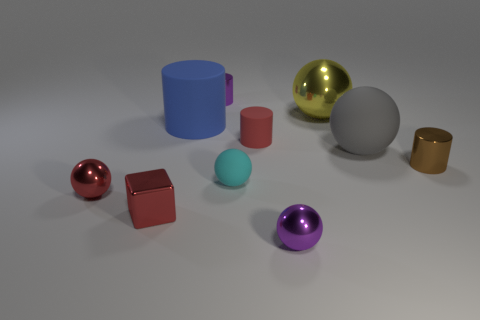Subtract 3 balls. How many balls are left? 2 Subtract all yellow spheres. How many spheres are left? 4 Subtract all purple shiny cylinders. How many cylinders are left? 3 Subtract all green cylinders. Subtract all gray blocks. How many cylinders are left? 4 Subtract all cylinders. How many objects are left? 6 Subtract 0 green blocks. How many objects are left? 10 Subtract all yellow matte cylinders. Subtract all purple shiny spheres. How many objects are left? 9 Add 5 large blue cylinders. How many large blue cylinders are left? 6 Add 5 green matte blocks. How many green matte blocks exist? 5 